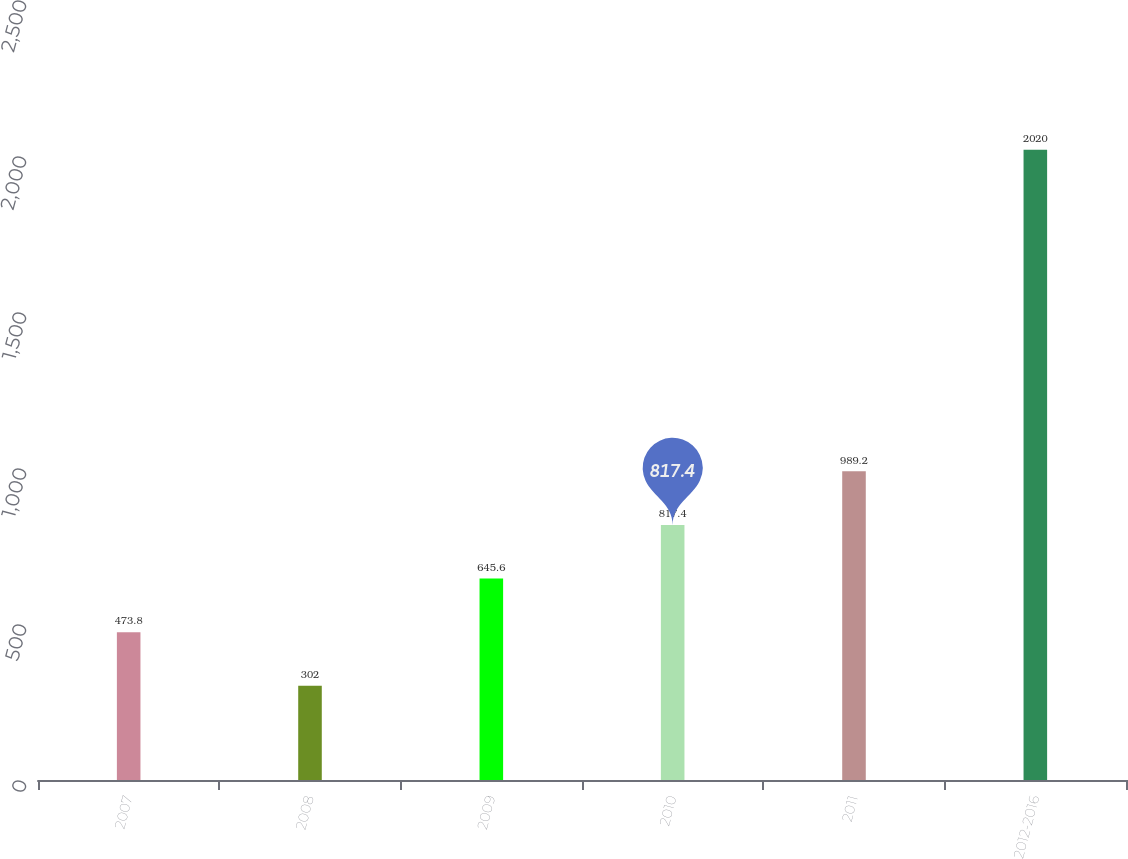Convert chart to OTSL. <chart><loc_0><loc_0><loc_500><loc_500><bar_chart><fcel>2007<fcel>2008<fcel>2009<fcel>2010<fcel>2011<fcel>2012-2016<nl><fcel>473.8<fcel>302<fcel>645.6<fcel>817.4<fcel>989.2<fcel>2020<nl></chart> 